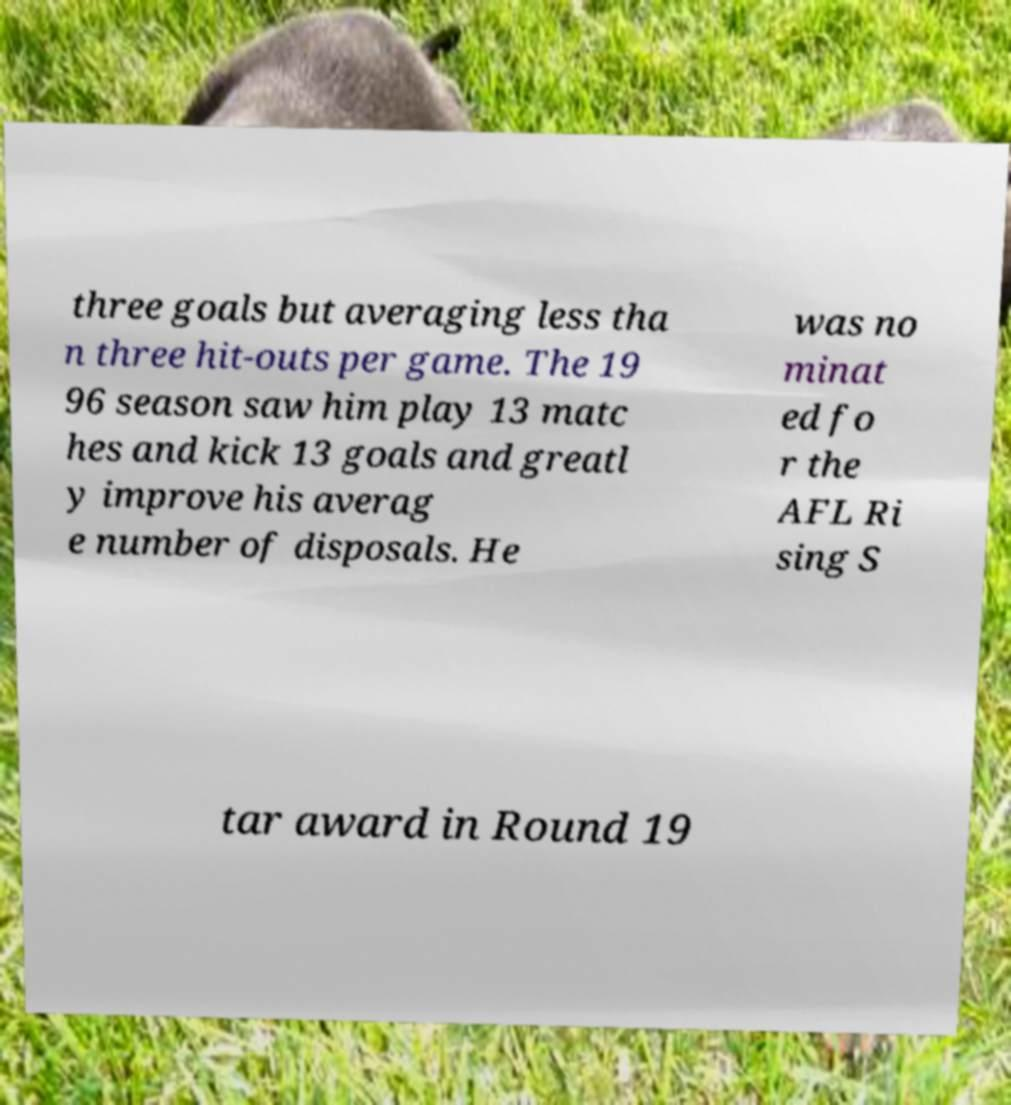What messages or text are displayed in this image? I need them in a readable, typed format. three goals but averaging less tha n three hit-outs per game. The 19 96 season saw him play 13 matc hes and kick 13 goals and greatl y improve his averag e number of disposals. He was no minat ed fo r the AFL Ri sing S tar award in Round 19 